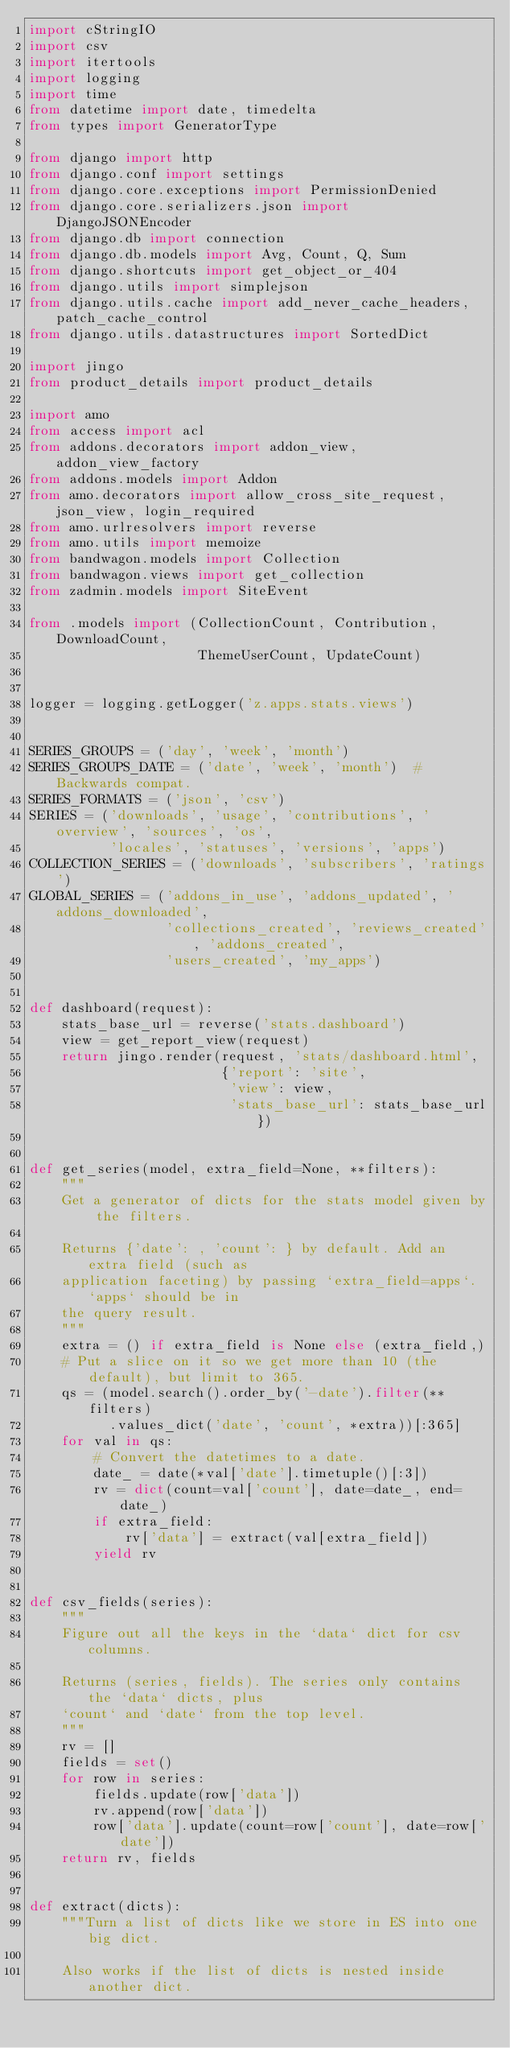<code> <loc_0><loc_0><loc_500><loc_500><_Python_>import cStringIO
import csv
import itertools
import logging
import time
from datetime import date, timedelta
from types import GeneratorType

from django import http
from django.conf import settings
from django.core.exceptions import PermissionDenied
from django.core.serializers.json import DjangoJSONEncoder
from django.db import connection
from django.db.models import Avg, Count, Q, Sum
from django.shortcuts import get_object_or_404
from django.utils import simplejson
from django.utils.cache import add_never_cache_headers, patch_cache_control
from django.utils.datastructures import SortedDict

import jingo
from product_details import product_details

import amo
from access import acl
from addons.decorators import addon_view, addon_view_factory
from addons.models import Addon
from amo.decorators import allow_cross_site_request, json_view, login_required
from amo.urlresolvers import reverse
from amo.utils import memoize
from bandwagon.models import Collection
from bandwagon.views import get_collection
from zadmin.models import SiteEvent

from .models import (CollectionCount, Contribution, DownloadCount,
                     ThemeUserCount, UpdateCount)


logger = logging.getLogger('z.apps.stats.views')


SERIES_GROUPS = ('day', 'week', 'month')
SERIES_GROUPS_DATE = ('date', 'week', 'month')  # Backwards compat.
SERIES_FORMATS = ('json', 'csv')
SERIES = ('downloads', 'usage', 'contributions', 'overview', 'sources', 'os',
          'locales', 'statuses', 'versions', 'apps')
COLLECTION_SERIES = ('downloads', 'subscribers', 'ratings')
GLOBAL_SERIES = ('addons_in_use', 'addons_updated', 'addons_downloaded',
                 'collections_created', 'reviews_created', 'addons_created',
                 'users_created', 'my_apps')


def dashboard(request):
    stats_base_url = reverse('stats.dashboard')
    view = get_report_view(request)
    return jingo.render(request, 'stats/dashboard.html',
                        {'report': 'site',
                         'view': view,
                         'stats_base_url': stats_base_url})


def get_series(model, extra_field=None, **filters):
    """
    Get a generator of dicts for the stats model given by the filters.

    Returns {'date': , 'count': } by default. Add an extra field (such as
    application faceting) by passing `extra_field=apps`. `apps` should be in
    the query result.
    """
    extra = () if extra_field is None else (extra_field,)
    # Put a slice on it so we get more than 10 (the default), but limit to 365.
    qs = (model.search().order_by('-date').filter(**filters)
          .values_dict('date', 'count', *extra))[:365]
    for val in qs:
        # Convert the datetimes to a date.
        date_ = date(*val['date'].timetuple()[:3])
        rv = dict(count=val['count'], date=date_, end=date_)
        if extra_field:
            rv['data'] = extract(val[extra_field])
        yield rv


def csv_fields(series):
    """
    Figure out all the keys in the `data` dict for csv columns.

    Returns (series, fields). The series only contains the `data` dicts, plus
    `count` and `date` from the top level.
    """
    rv = []
    fields = set()
    for row in series:
        fields.update(row['data'])
        rv.append(row['data'])
        row['data'].update(count=row['count'], date=row['date'])
    return rv, fields


def extract(dicts):
    """Turn a list of dicts like we store in ES into one big dict.

    Also works if the list of dicts is nested inside another dict.
</code> 